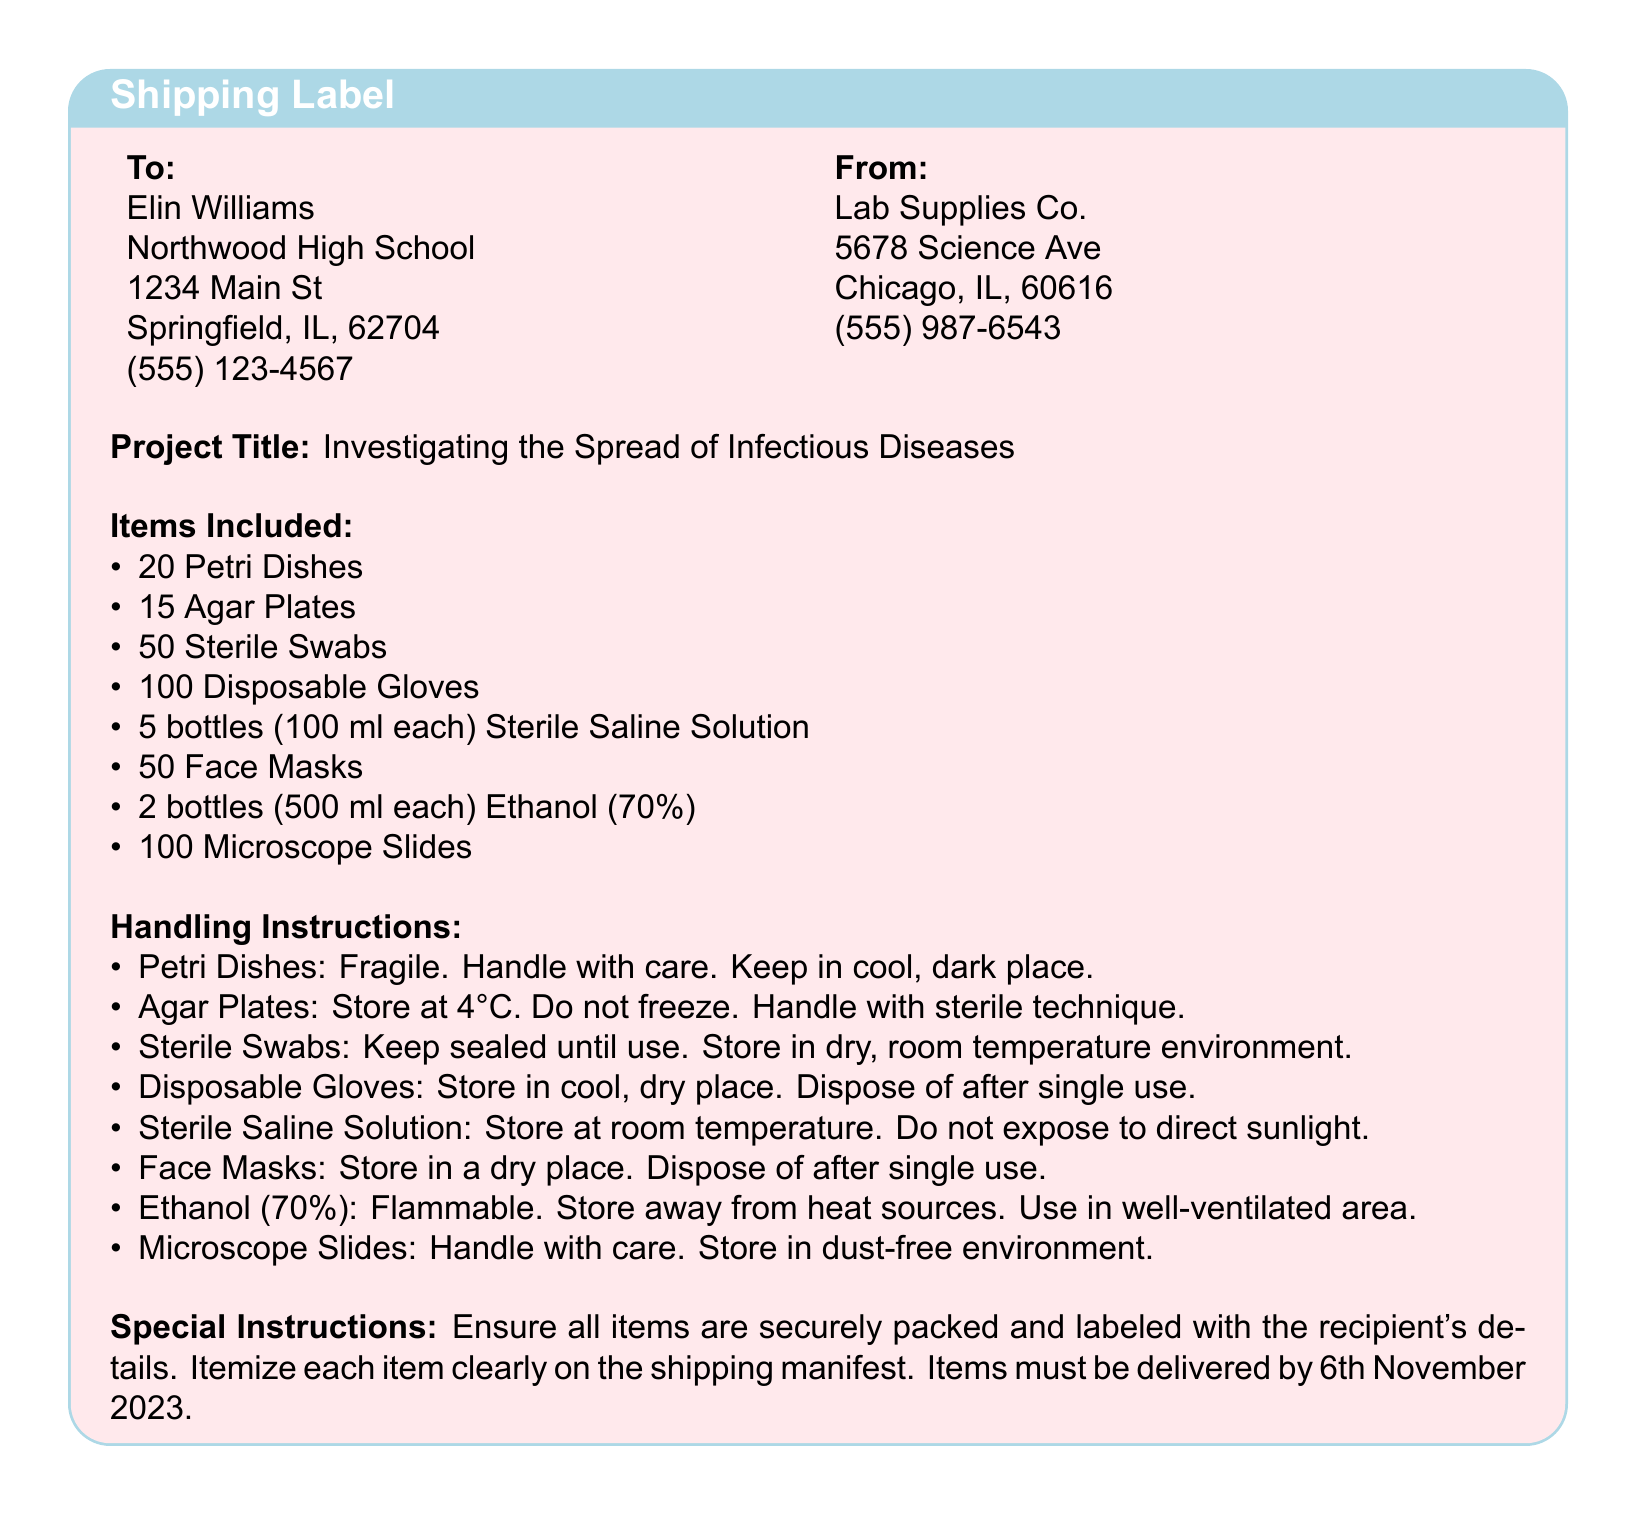what is the recipient's name? The recipient's name is listed in the "To" section of the shipping label.
Answer: Elin Williams what is the project title? The project title is specified under the "Project Title" section of the document.
Answer: Investigating the Spread of Infectious Diseases how many Petri Dishes are included? The number of Petri Dishes is mentioned in the "Items Included" section.
Answer: 20 what is the storage temperature for Agar Plates? The handling instruction for Agar Plates mentions the required storage temperature.
Answer: 4°C what should be done with Disposable Gloves after use? The handling instruction for Disposable Gloves specifies their disposal.
Answer: Dispose of after single use which item is stored away from heat sources? The handling instructions indicate which item should be stored away from heat sources.
Answer: Ethanol (70%) when is the delivery date for the items? The special instructions mention the required delivery date for the shipment.
Answer: 6th November 2023 what type of document is this? The overall content and format suggest the type of document this is.
Answer: Shipping label what should be ensured about the packing of items? The special instructions highlight what must be ensured about the packing of items.
Answer: Securely packed and labeled 